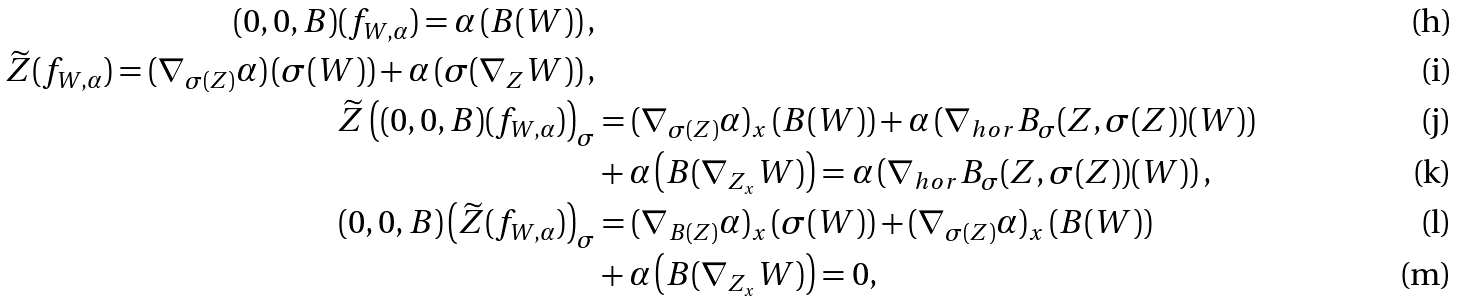<formula> <loc_0><loc_0><loc_500><loc_500>( 0 , 0 , B ) ( f _ { W , \alpha } ) = \alpha \left ( B ( W ) \right ) , \\ \widetilde { Z } ( f _ { W , \alpha } ) = ( \nabla _ { \sigma ( Z ) } \alpha ) \left ( \sigma ( W ) \right ) + \alpha \left ( \sigma ( \nabla _ { Z } W ) \right ) , \\ \widetilde { Z } \left ( ( 0 , 0 , B ) ( f _ { W , \alpha } ) \right ) _ { \sigma } & = ( \nabla _ { \sigma ( Z ) } \alpha ) _ { x } \left ( B ( W ) \right ) + \alpha \left ( \nabla _ { h o r } B _ { \sigma } ( Z , \sigma ( Z ) ) ( W ) \right ) \\ & + \alpha \left ( B ( \nabla _ { Z _ { x } } W ) \right ) = \alpha \left ( \nabla _ { h o r } B _ { \sigma } ( Z , \sigma ( Z ) ) ( W ) \right ) , \\ ( 0 , 0 , B ) \left ( \widetilde { Z } ( f _ { W , \alpha } ) \right ) _ { \sigma } & = ( \nabla _ { B ( Z ) } \alpha ) _ { x } \left ( \sigma ( W ) \right ) + ( \nabla _ { \sigma ( Z ) } \alpha ) _ { x } \left ( B ( W ) \right ) \\ & + \alpha \left ( B ( \nabla _ { Z _ { x } } W ) \right ) = 0 ,</formula> 